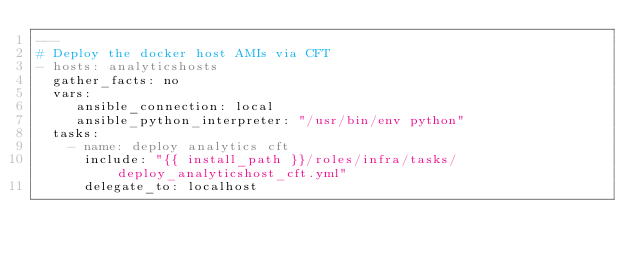Convert code to text. <code><loc_0><loc_0><loc_500><loc_500><_YAML_>---
# Deploy the docker host AMIs via CFT
- hosts: analyticshosts
  gather_facts: no
  vars:
     ansible_connection: local
     ansible_python_interpreter: "/usr/bin/env python"
  tasks:
    - name: deploy analytics cft 
      include: "{{ install_path }}/roles/infra/tasks/deploy_analyticshost_cft.yml"
      delegate_to: localhost
</code> 